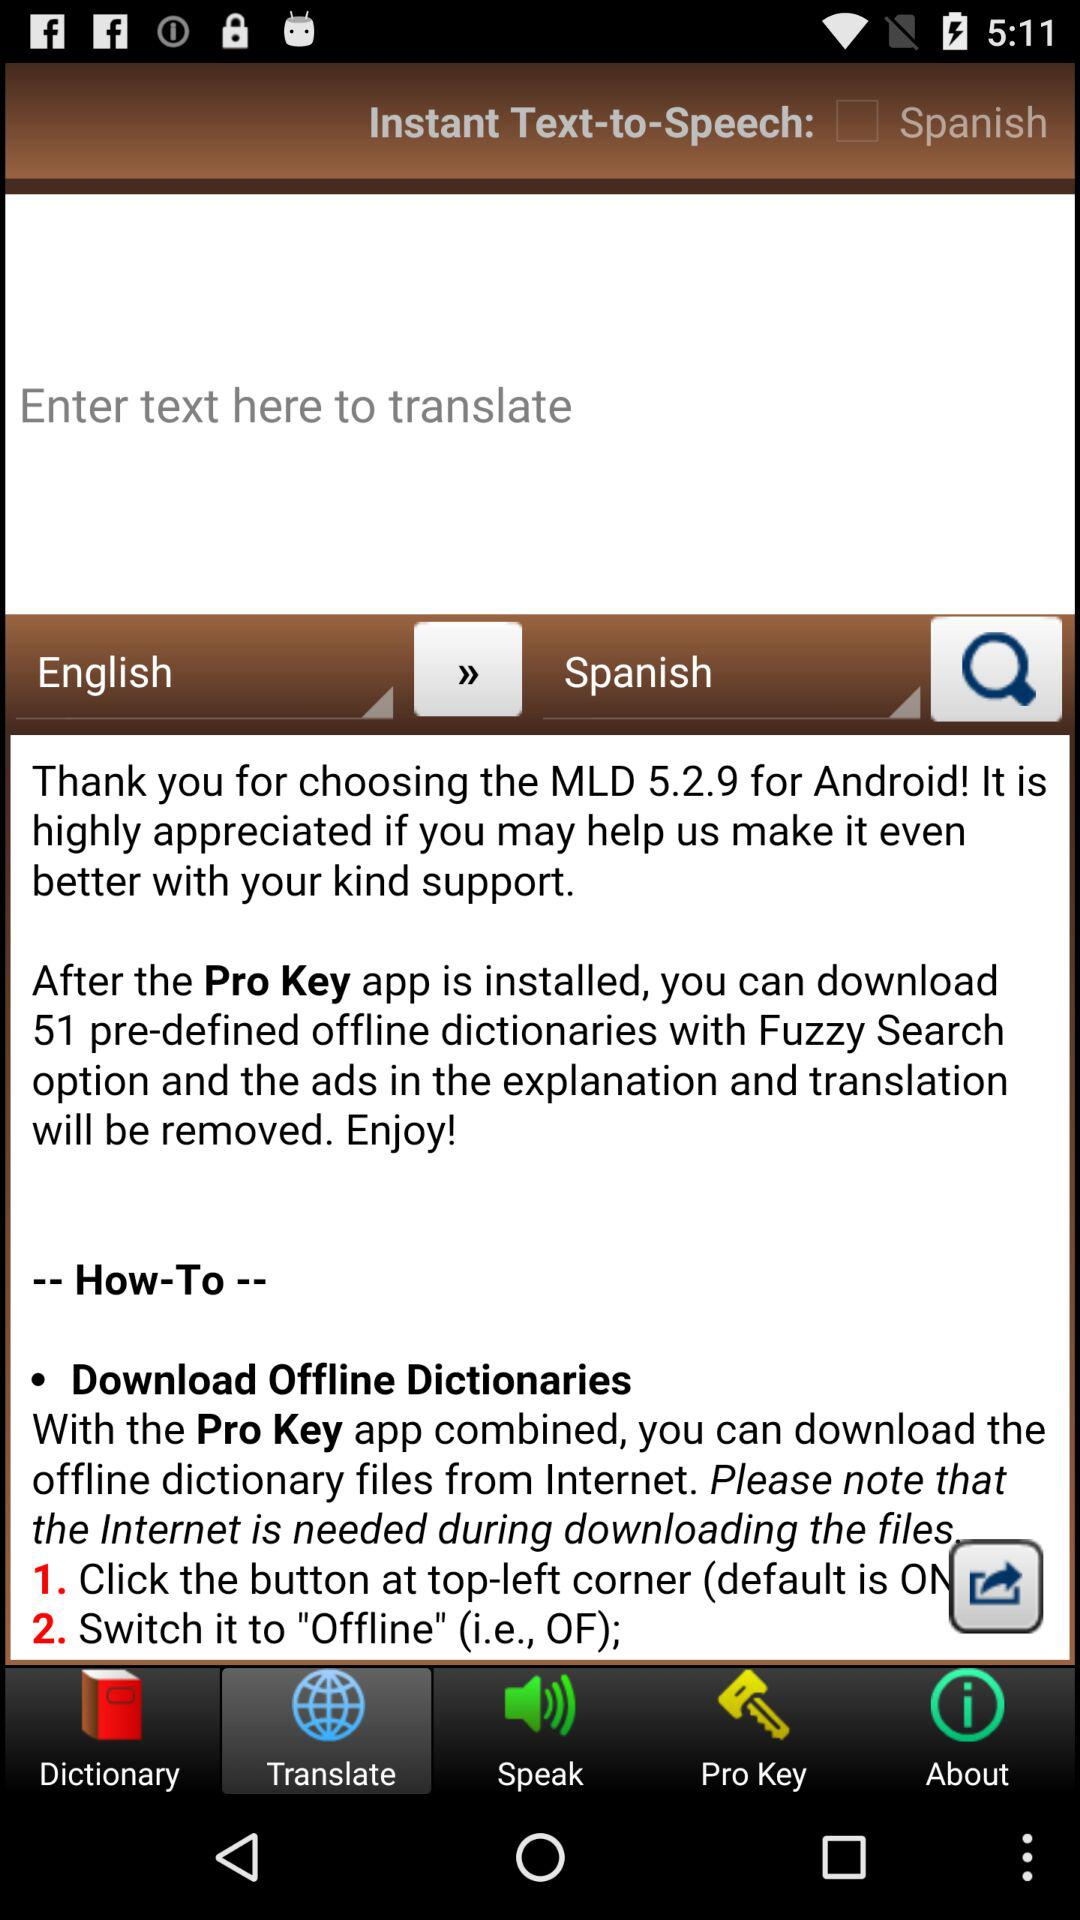Which android is used?
When the provided information is insufficient, respond with <no answer>. <no answer> 